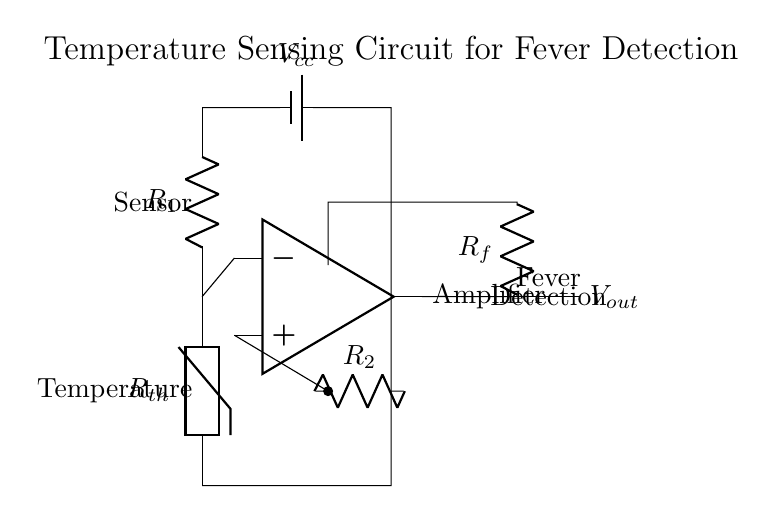What type of sensor is used in this circuit? The circuit uses a thermistor as the temperature sensor, which is indicated by the label \( R_{th} \).
Answer: Thermistor What is the purpose of the operational amplifier? The operational amplifier amplifies the signal from the thermistor, allowing for clearer readings of the temperature. It is represented by the labeled op-amp symbol in the circuit.
Answer: Amplification How many resistors are present in the circuit? There are three resistors: \( R_{th} \), \( R_1 \), and \( R_2 \), as indicated by their labels in the diagram.
Answer: Three What is the function of \( R_f \) in this circuit? \( R_f \) is likely used as a feedback resistor to stabilize and set the gain of the operational amplifier, as suggested by its position in the feedback loop.
Answer: Feedback What is the output of the circuit labeled as? The output of the circuit is labeled as \( V_{out} \), which indicates the voltage output from the operational amplifier.
Answer: Vout How is the thermistor connected in the circuit? The thermistor is configured in a voltage divider arrangement with \( R_1 \) above it, allowing it to measure varying temperature levels and create a proportional voltage drop.
Answer: Voltage divider What does \( V_{cc} \) represent in this circuit? \( V_{cc} \) represents the power supply voltage for the circuit, powering the components including the operational amplifier and the thermistor.
Answer: Power supply 